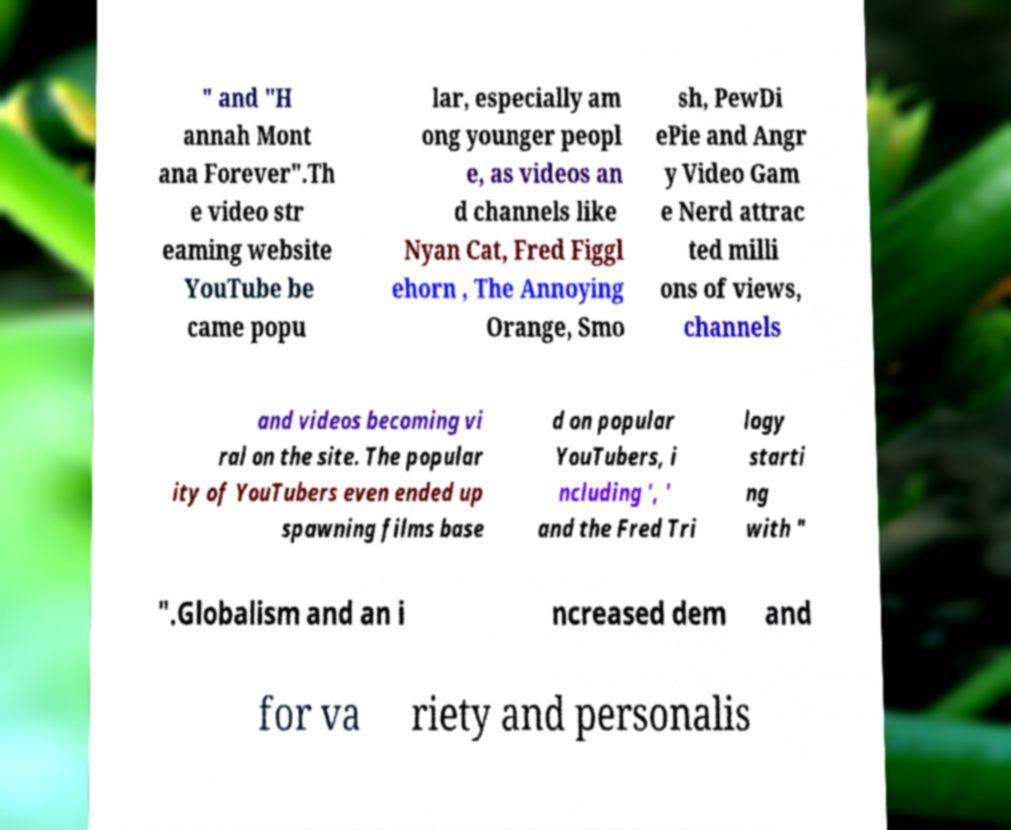Can you accurately transcribe the text from the provided image for me? " and "H annah Mont ana Forever".Th e video str eaming website YouTube be came popu lar, especially am ong younger peopl e, as videos an d channels like Nyan Cat, Fred Figgl ehorn , The Annoying Orange, Smo sh, PewDi ePie and Angr y Video Gam e Nerd attrac ted milli ons of views, channels and videos becoming vi ral on the site. The popular ity of YouTubers even ended up spawning films base d on popular YouTubers, i ncluding ', ' and the Fred Tri logy starti ng with " ".Globalism and an i ncreased dem and for va riety and personalis 